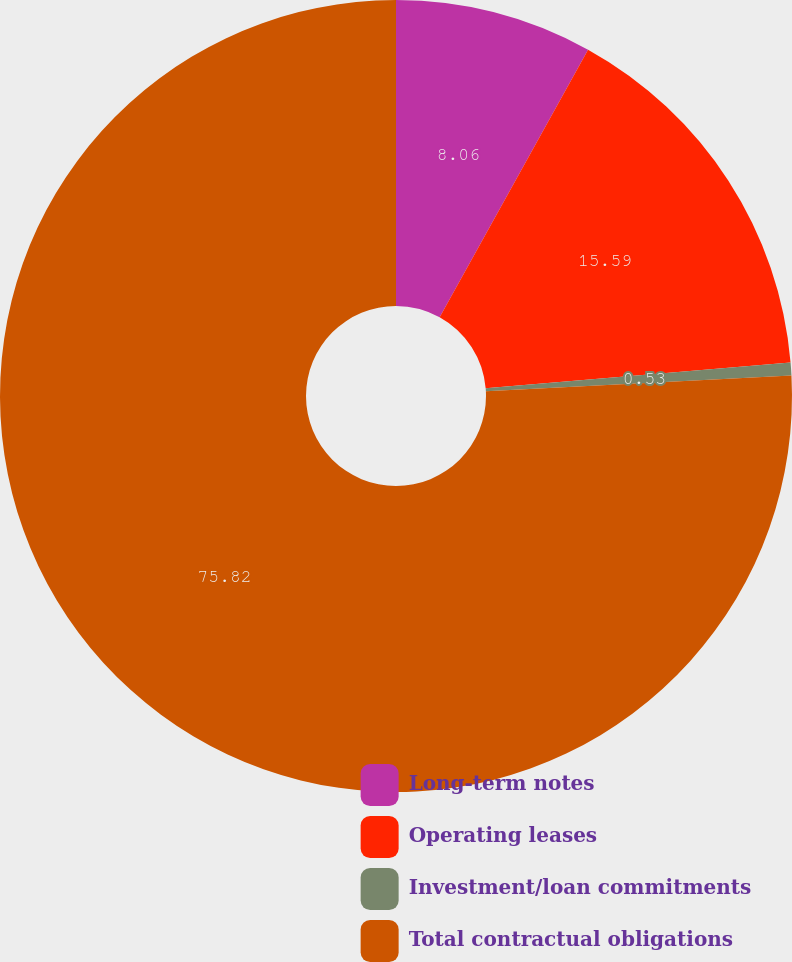Convert chart to OTSL. <chart><loc_0><loc_0><loc_500><loc_500><pie_chart><fcel>Long-term notes<fcel>Operating leases<fcel>Investment/loan commitments<fcel>Total contractual obligations<nl><fcel>8.06%<fcel>15.59%<fcel>0.53%<fcel>75.83%<nl></chart> 